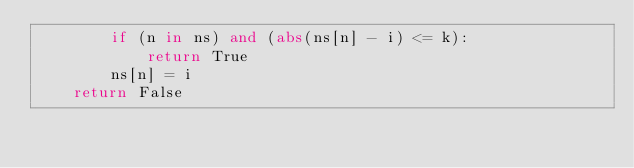Convert code to text. <code><loc_0><loc_0><loc_500><loc_500><_Python_>        if (n in ns) and (abs(ns[n] - i) <= k):
            return True
        ns[n] = i
    return False
</code> 